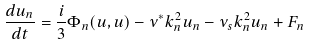Convert formula to latex. <formula><loc_0><loc_0><loc_500><loc_500>\frac { d u _ { n } } { d t } = \frac { i } { 3 } \Phi _ { n } ( u , u ) - \nu ^ { * } k _ { n } ^ { 2 } u _ { n } - \nu _ { s } k ^ { 2 } _ { n } u _ { n } + F _ { n }</formula> 